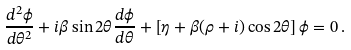<formula> <loc_0><loc_0><loc_500><loc_500>\frac { d ^ { 2 } \phi } { d \theta ^ { 2 } } + i \beta \sin 2 \theta \frac { d \phi } { d \theta } + \left [ \eta + \beta ( \rho + i ) \cos 2 \theta \right ] \phi = 0 \, .</formula> 